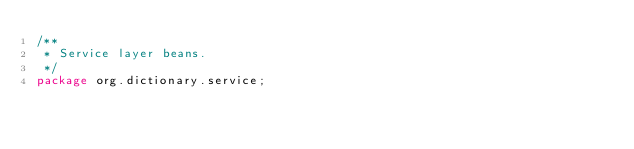Convert code to text. <code><loc_0><loc_0><loc_500><loc_500><_Java_>/**
 * Service layer beans.
 */
package org.dictionary.service;
</code> 